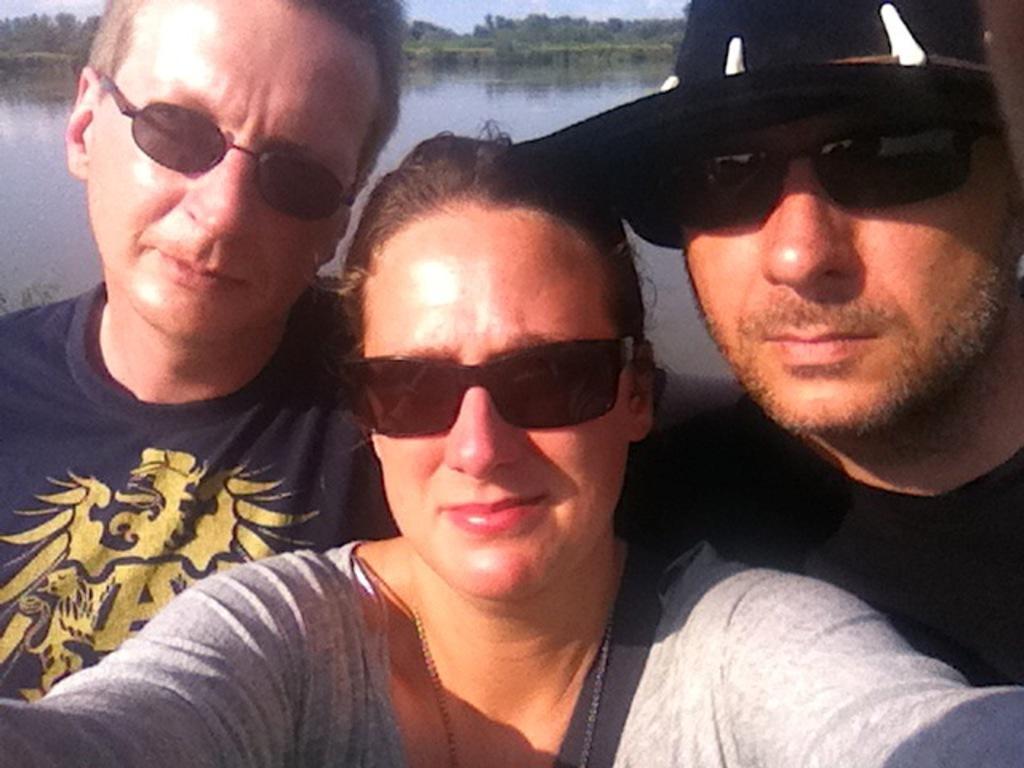Can you describe this image briefly? In this image, we can see three persons wearing clothes and sunglasses in front of the lake. 